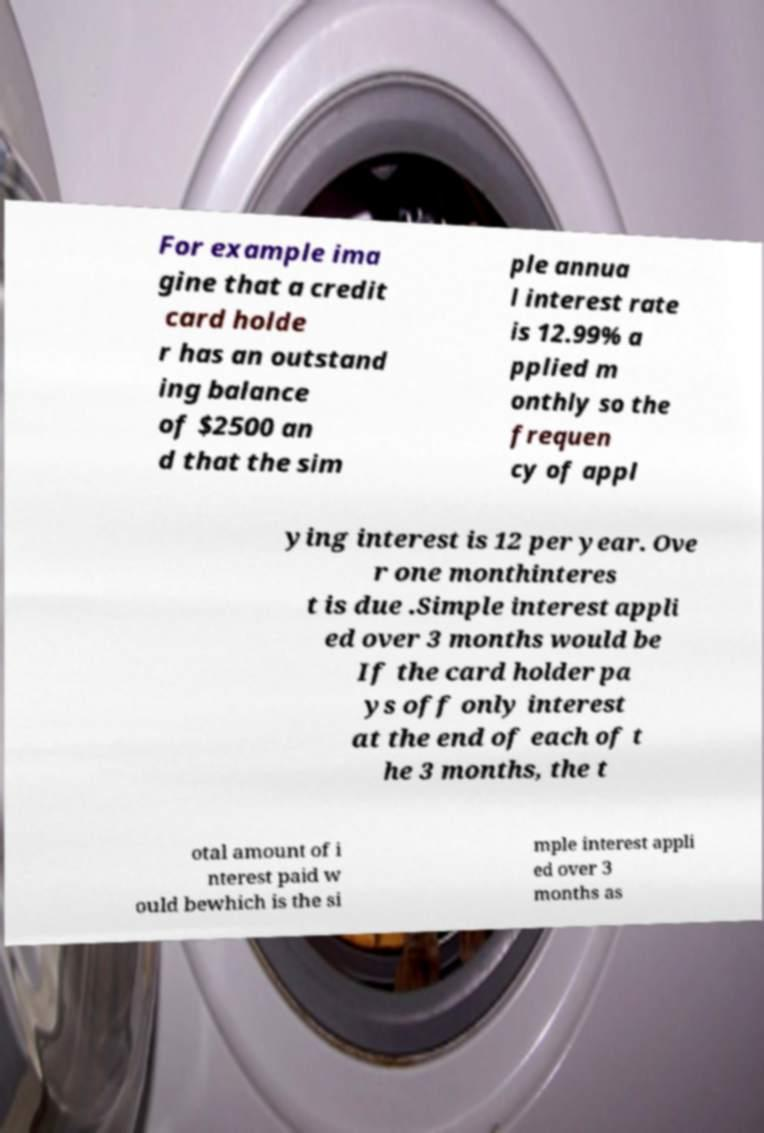Please read and relay the text visible in this image. What does it say? For example ima gine that a credit card holde r has an outstand ing balance of $2500 an d that the sim ple annua l interest rate is 12.99% a pplied m onthly so the frequen cy of appl ying interest is 12 per year. Ove r one monthinteres t is due .Simple interest appli ed over 3 months would be If the card holder pa ys off only interest at the end of each of t he 3 months, the t otal amount of i nterest paid w ould bewhich is the si mple interest appli ed over 3 months as 